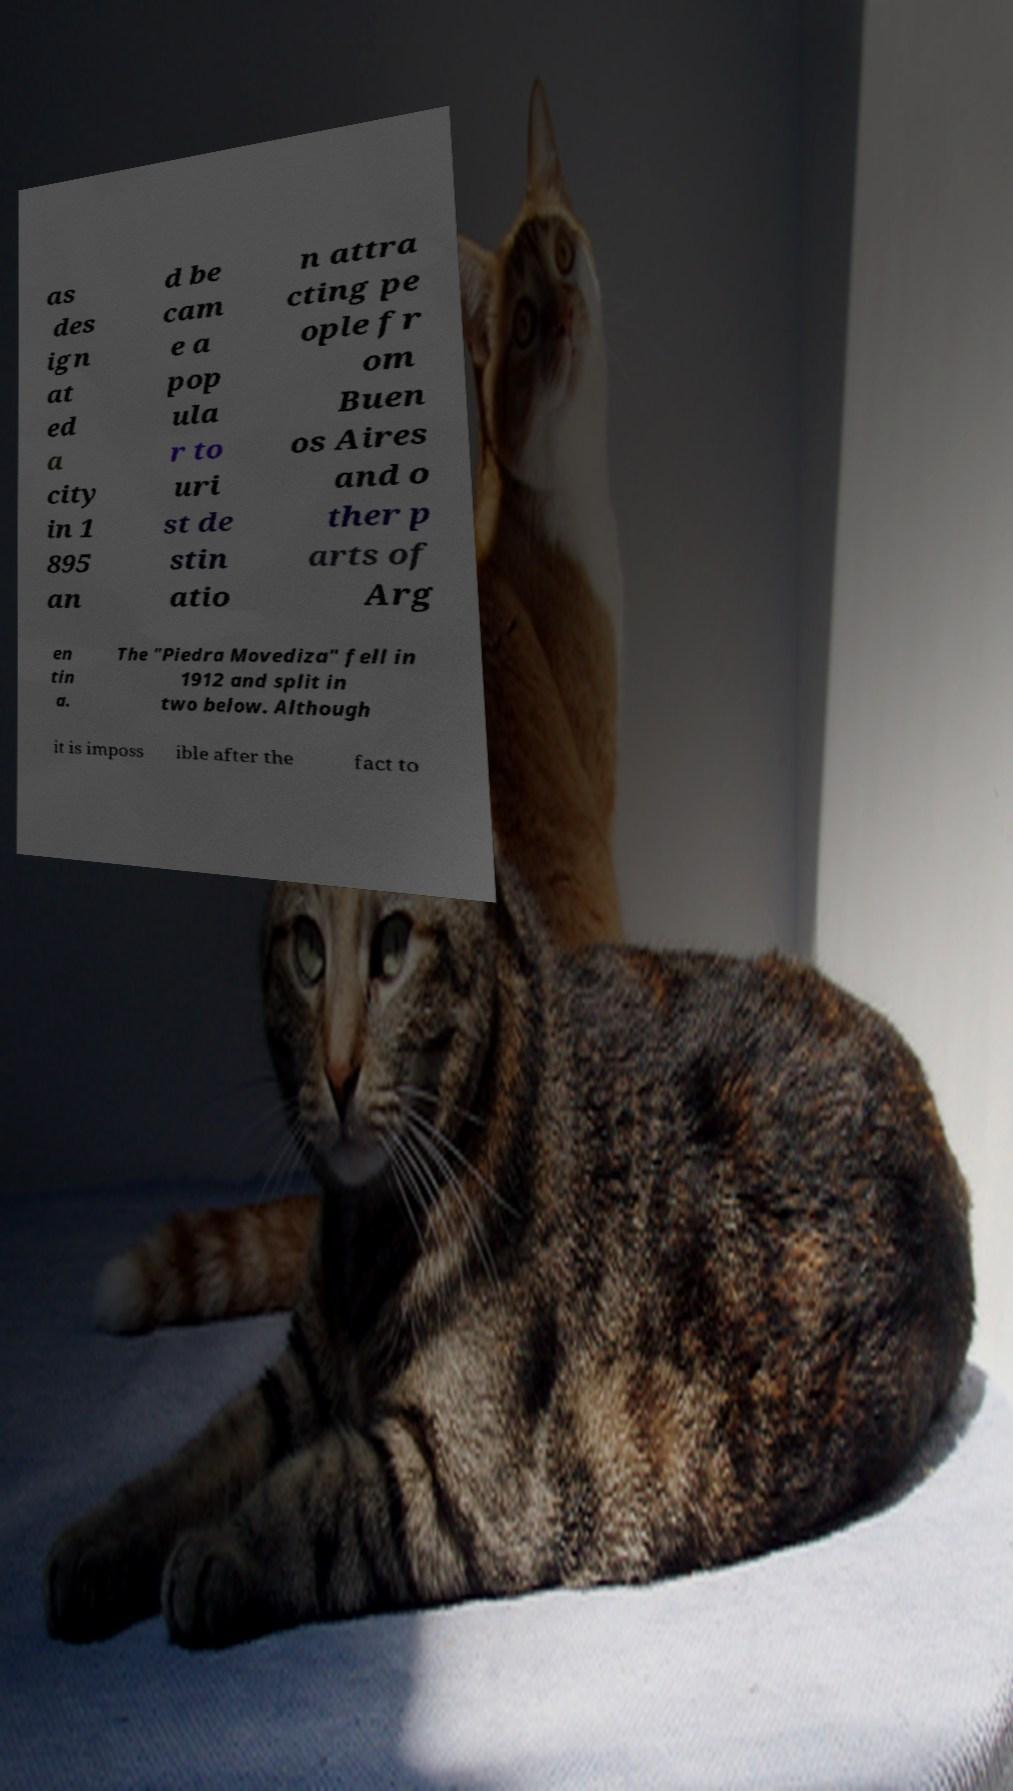What messages or text are displayed in this image? I need them in a readable, typed format. as des ign at ed a city in 1 895 an d be cam e a pop ula r to uri st de stin atio n attra cting pe ople fr om Buen os Aires and o ther p arts of Arg en tin a. The "Piedra Movediza" fell in 1912 and split in two below. Although it is imposs ible after the fact to 